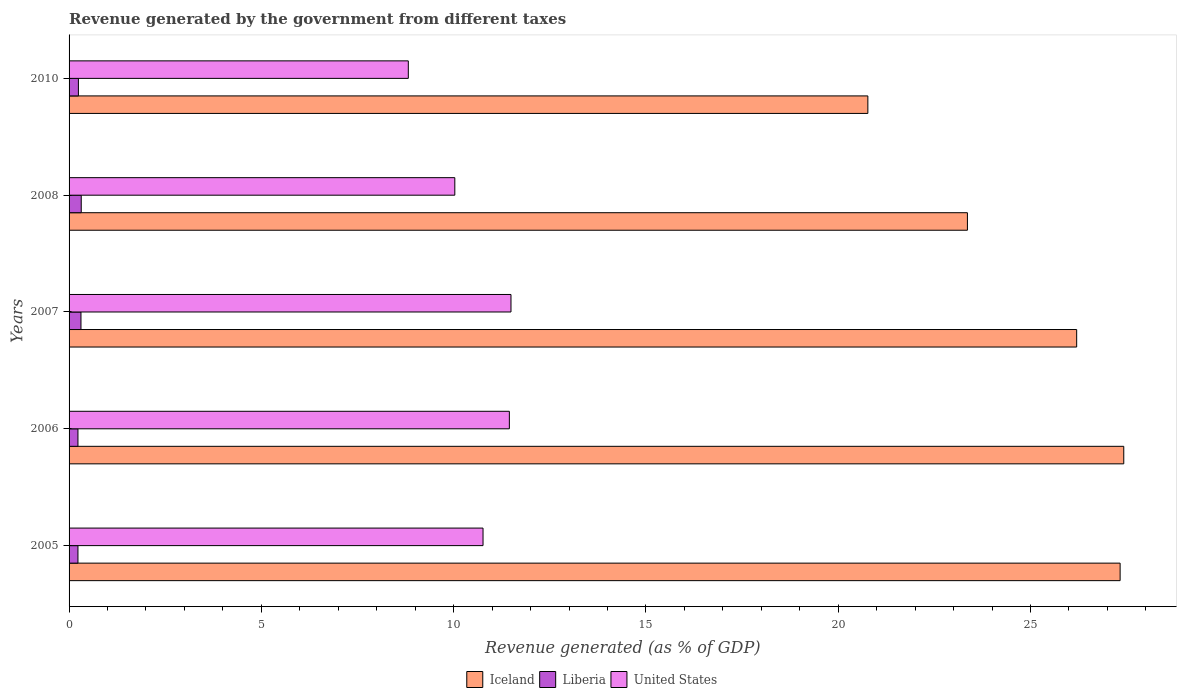How many different coloured bars are there?
Provide a succinct answer. 3. How many groups of bars are there?
Offer a very short reply. 5. How many bars are there on the 3rd tick from the bottom?
Ensure brevity in your answer.  3. What is the revenue generated by the government in Iceland in 2005?
Make the answer very short. 27.33. Across all years, what is the maximum revenue generated by the government in Liberia?
Provide a succinct answer. 0.32. Across all years, what is the minimum revenue generated by the government in United States?
Keep it short and to the point. 8.82. In which year was the revenue generated by the government in Liberia minimum?
Offer a very short reply. 2005. What is the total revenue generated by the government in United States in the graph?
Your answer should be very brief. 52.55. What is the difference between the revenue generated by the government in Iceland in 2005 and that in 2007?
Your answer should be compact. 1.13. What is the difference between the revenue generated by the government in United States in 2006 and the revenue generated by the government in Iceland in 2008?
Give a very brief answer. -11.91. What is the average revenue generated by the government in Iceland per year?
Offer a terse response. 25.02. In the year 2007, what is the difference between the revenue generated by the government in Liberia and revenue generated by the government in United States?
Your answer should be very brief. -11.18. In how many years, is the revenue generated by the government in Iceland greater than 13 %?
Give a very brief answer. 5. What is the ratio of the revenue generated by the government in Liberia in 2005 to that in 2010?
Offer a terse response. 0.95. Is the revenue generated by the government in United States in 2007 less than that in 2010?
Provide a short and direct response. No. What is the difference between the highest and the second highest revenue generated by the government in United States?
Make the answer very short. 0.04. What is the difference between the highest and the lowest revenue generated by the government in United States?
Provide a succinct answer. 2.67. In how many years, is the revenue generated by the government in Liberia greater than the average revenue generated by the government in Liberia taken over all years?
Keep it short and to the point. 2. What does the 2nd bar from the top in 2010 represents?
Offer a terse response. Liberia. What does the 2nd bar from the bottom in 2005 represents?
Keep it short and to the point. Liberia. Are all the bars in the graph horizontal?
Keep it short and to the point. Yes. How many years are there in the graph?
Provide a short and direct response. 5. What is the difference between two consecutive major ticks on the X-axis?
Provide a short and direct response. 5. What is the title of the graph?
Provide a short and direct response. Revenue generated by the government from different taxes. What is the label or title of the X-axis?
Your response must be concise. Revenue generated (as % of GDP). What is the label or title of the Y-axis?
Provide a succinct answer. Years. What is the Revenue generated (as % of GDP) of Iceland in 2005?
Your answer should be compact. 27.33. What is the Revenue generated (as % of GDP) of Liberia in 2005?
Offer a terse response. 0.23. What is the Revenue generated (as % of GDP) of United States in 2005?
Keep it short and to the point. 10.76. What is the Revenue generated (as % of GDP) in Iceland in 2006?
Provide a short and direct response. 27.42. What is the Revenue generated (as % of GDP) of Liberia in 2006?
Give a very brief answer. 0.23. What is the Revenue generated (as % of GDP) in United States in 2006?
Ensure brevity in your answer.  11.45. What is the Revenue generated (as % of GDP) in Iceland in 2007?
Make the answer very short. 26.2. What is the Revenue generated (as % of GDP) of Liberia in 2007?
Your response must be concise. 0.31. What is the Revenue generated (as % of GDP) of United States in 2007?
Ensure brevity in your answer.  11.49. What is the Revenue generated (as % of GDP) of Iceland in 2008?
Provide a succinct answer. 23.36. What is the Revenue generated (as % of GDP) of Liberia in 2008?
Offer a very short reply. 0.32. What is the Revenue generated (as % of GDP) of United States in 2008?
Your answer should be compact. 10.03. What is the Revenue generated (as % of GDP) of Iceland in 2010?
Offer a very short reply. 20.77. What is the Revenue generated (as % of GDP) of Liberia in 2010?
Provide a short and direct response. 0.24. What is the Revenue generated (as % of GDP) in United States in 2010?
Offer a very short reply. 8.82. Across all years, what is the maximum Revenue generated (as % of GDP) in Iceland?
Provide a succinct answer. 27.42. Across all years, what is the maximum Revenue generated (as % of GDP) in Liberia?
Your response must be concise. 0.32. Across all years, what is the maximum Revenue generated (as % of GDP) of United States?
Keep it short and to the point. 11.49. Across all years, what is the minimum Revenue generated (as % of GDP) in Iceland?
Ensure brevity in your answer.  20.77. Across all years, what is the minimum Revenue generated (as % of GDP) in Liberia?
Ensure brevity in your answer.  0.23. Across all years, what is the minimum Revenue generated (as % of GDP) in United States?
Ensure brevity in your answer.  8.82. What is the total Revenue generated (as % of GDP) in Iceland in the graph?
Offer a terse response. 125.08. What is the total Revenue generated (as % of GDP) of Liberia in the graph?
Your answer should be very brief. 1.33. What is the total Revenue generated (as % of GDP) of United States in the graph?
Give a very brief answer. 52.55. What is the difference between the Revenue generated (as % of GDP) in Iceland in 2005 and that in 2006?
Keep it short and to the point. -0.09. What is the difference between the Revenue generated (as % of GDP) in Liberia in 2005 and that in 2006?
Offer a terse response. -0. What is the difference between the Revenue generated (as % of GDP) of United States in 2005 and that in 2006?
Your answer should be compact. -0.68. What is the difference between the Revenue generated (as % of GDP) of Iceland in 2005 and that in 2007?
Your answer should be compact. 1.13. What is the difference between the Revenue generated (as % of GDP) in Liberia in 2005 and that in 2007?
Make the answer very short. -0.08. What is the difference between the Revenue generated (as % of GDP) in United States in 2005 and that in 2007?
Your answer should be very brief. -0.73. What is the difference between the Revenue generated (as % of GDP) in Iceland in 2005 and that in 2008?
Your response must be concise. 3.97. What is the difference between the Revenue generated (as % of GDP) of Liberia in 2005 and that in 2008?
Provide a succinct answer. -0.09. What is the difference between the Revenue generated (as % of GDP) in United States in 2005 and that in 2008?
Provide a succinct answer. 0.73. What is the difference between the Revenue generated (as % of GDP) in Iceland in 2005 and that in 2010?
Your answer should be compact. 6.56. What is the difference between the Revenue generated (as % of GDP) of Liberia in 2005 and that in 2010?
Your answer should be compact. -0.01. What is the difference between the Revenue generated (as % of GDP) in United States in 2005 and that in 2010?
Provide a succinct answer. 1.94. What is the difference between the Revenue generated (as % of GDP) in Iceland in 2006 and that in 2007?
Keep it short and to the point. 1.22. What is the difference between the Revenue generated (as % of GDP) of Liberia in 2006 and that in 2007?
Offer a very short reply. -0.08. What is the difference between the Revenue generated (as % of GDP) in United States in 2006 and that in 2007?
Your answer should be very brief. -0.04. What is the difference between the Revenue generated (as % of GDP) of Iceland in 2006 and that in 2008?
Give a very brief answer. 4.07. What is the difference between the Revenue generated (as % of GDP) in Liberia in 2006 and that in 2008?
Make the answer very short. -0.09. What is the difference between the Revenue generated (as % of GDP) of United States in 2006 and that in 2008?
Offer a terse response. 1.42. What is the difference between the Revenue generated (as % of GDP) in Iceland in 2006 and that in 2010?
Your response must be concise. 6.65. What is the difference between the Revenue generated (as % of GDP) of Liberia in 2006 and that in 2010?
Your answer should be very brief. -0.01. What is the difference between the Revenue generated (as % of GDP) in United States in 2006 and that in 2010?
Give a very brief answer. 2.63. What is the difference between the Revenue generated (as % of GDP) in Iceland in 2007 and that in 2008?
Offer a terse response. 2.84. What is the difference between the Revenue generated (as % of GDP) of Liberia in 2007 and that in 2008?
Provide a succinct answer. -0.01. What is the difference between the Revenue generated (as % of GDP) of United States in 2007 and that in 2008?
Make the answer very short. 1.46. What is the difference between the Revenue generated (as % of GDP) in Iceland in 2007 and that in 2010?
Provide a succinct answer. 5.43. What is the difference between the Revenue generated (as % of GDP) in Liberia in 2007 and that in 2010?
Your response must be concise. 0.07. What is the difference between the Revenue generated (as % of GDP) in United States in 2007 and that in 2010?
Make the answer very short. 2.67. What is the difference between the Revenue generated (as % of GDP) in Iceland in 2008 and that in 2010?
Your response must be concise. 2.59. What is the difference between the Revenue generated (as % of GDP) of Liberia in 2008 and that in 2010?
Give a very brief answer. 0.07. What is the difference between the Revenue generated (as % of GDP) in United States in 2008 and that in 2010?
Provide a short and direct response. 1.21. What is the difference between the Revenue generated (as % of GDP) of Iceland in 2005 and the Revenue generated (as % of GDP) of Liberia in 2006?
Your answer should be compact. 27.1. What is the difference between the Revenue generated (as % of GDP) in Iceland in 2005 and the Revenue generated (as % of GDP) in United States in 2006?
Provide a short and direct response. 15.88. What is the difference between the Revenue generated (as % of GDP) of Liberia in 2005 and the Revenue generated (as % of GDP) of United States in 2006?
Ensure brevity in your answer.  -11.22. What is the difference between the Revenue generated (as % of GDP) of Iceland in 2005 and the Revenue generated (as % of GDP) of Liberia in 2007?
Offer a very short reply. 27.02. What is the difference between the Revenue generated (as % of GDP) of Iceland in 2005 and the Revenue generated (as % of GDP) of United States in 2007?
Keep it short and to the point. 15.84. What is the difference between the Revenue generated (as % of GDP) in Liberia in 2005 and the Revenue generated (as % of GDP) in United States in 2007?
Your answer should be very brief. -11.26. What is the difference between the Revenue generated (as % of GDP) in Iceland in 2005 and the Revenue generated (as % of GDP) in Liberia in 2008?
Give a very brief answer. 27.01. What is the difference between the Revenue generated (as % of GDP) in Iceland in 2005 and the Revenue generated (as % of GDP) in United States in 2008?
Provide a succinct answer. 17.3. What is the difference between the Revenue generated (as % of GDP) of Liberia in 2005 and the Revenue generated (as % of GDP) of United States in 2008?
Offer a terse response. -9.8. What is the difference between the Revenue generated (as % of GDP) in Iceland in 2005 and the Revenue generated (as % of GDP) in Liberia in 2010?
Your answer should be very brief. 27.09. What is the difference between the Revenue generated (as % of GDP) in Iceland in 2005 and the Revenue generated (as % of GDP) in United States in 2010?
Keep it short and to the point. 18.51. What is the difference between the Revenue generated (as % of GDP) of Liberia in 2005 and the Revenue generated (as % of GDP) of United States in 2010?
Offer a very short reply. -8.59. What is the difference between the Revenue generated (as % of GDP) in Iceland in 2006 and the Revenue generated (as % of GDP) in Liberia in 2007?
Ensure brevity in your answer.  27.11. What is the difference between the Revenue generated (as % of GDP) in Iceland in 2006 and the Revenue generated (as % of GDP) in United States in 2007?
Give a very brief answer. 15.93. What is the difference between the Revenue generated (as % of GDP) in Liberia in 2006 and the Revenue generated (as % of GDP) in United States in 2007?
Your answer should be compact. -11.26. What is the difference between the Revenue generated (as % of GDP) in Iceland in 2006 and the Revenue generated (as % of GDP) in Liberia in 2008?
Offer a very short reply. 27.11. What is the difference between the Revenue generated (as % of GDP) in Iceland in 2006 and the Revenue generated (as % of GDP) in United States in 2008?
Give a very brief answer. 17.39. What is the difference between the Revenue generated (as % of GDP) in Liberia in 2006 and the Revenue generated (as % of GDP) in United States in 2008?
Your answer should be compact. -9.8. What is the difference between the Revenue generated (as % of GDP) of Iceland in 2006 and the Revenue generated (as % of GDP) of Liberia in 2010?
Your answer should be compact. 27.18. What is the difference between the Revenue generated (as % of GDP) of Iceland in 2006 and the Revenue generated (as % of GDP) of United States in 2010?
Ensure brevity in your answer.  18.6. What is the difference between the Revenue generated (as % of GDP) of Liberia in 2006 and the Revenue generated (as % of GDP) of United States in 2010?
Give a very brief answer. -8.59. What is the difference between the Revenue generated (as % of GDP) of Iceland in 2007 and the Revenue generated (as % of GDP) of Liberia in 2008?
Offer a terse response. 25.88. What is the difference between the Revenue generated (as % of GDP) of Iceland in 2007 and the Revenue generated (as % of GDP) of United States in 2008?
Provide a succinct answer. 16.17. What is the difference between the Revenue generated (as % of GDP) in Liberia in 2007 and the Revenue generated (as % of GDP) in United States in 2008?
Make the answer very short. -9.72. What is the difference between the Revenue generated (as % of GDP) in Iceland in 2007 and the Revenue generated (as % of GDP) in Liberia in 2010?
Your answer should be compact. 25.96. What is the difference between the Revenue generated (as % of GDP) in Iceland in 2007 and the Revenue generated (as % of GDP) in United States in 2010?
Ensure brevity in your answer.  17.38. What is the difference between the Revenue generated (as % of GDP) in Liberia in 2007 and the Revenue generated (as % of GDP) in United States in 2010?
Make the answer very short. -8.51. What is the difference between the Revenue generated (as % of GDP) in Iceland in 2008 and the Revenue generated (as % of GDP) in Liberia in 2010?
Keep it short and to the point. 23.12. What is the difference between the Revenue generated (as % of GDP) in Iceland in 2008 and the Revenue generated (as % of GDP) in United States in 2010?
Make the answer very short. 14.54. What is the difference between the Revenue generated (as % of GDP) in Liberia in 2008 and the Revenue generated (as % of GDP) in United States in 2010?
Make the answer very short. -8.5. What is the average Revenue generated (as % of GDP) in Iceland per year?
Ensure brevity in your answer.  25.02. What is the average Revenue generated (as % of GDP) of Liberia per year?
Keep it short and to the point. 0.27. What is the average Revenue generated (as % of GDP) of United States per year?
Your answer should be compact. 10.51. In the year 2005, what is the difference between the Revenue generated (as % of GDP) of Iceland and Revenue generated (as % of GDP) of Liberia?
Ensure brevity in your answer.  27.1. In the year 2005, what is the difference between the Revenue generated (as % of GDP) in Iceland and Revenue generated (as % of GDP) in United States?
Offer a very short reply. 16.57. In the year 2005, what is the difference between the Revenue generated (as % of GDP) of Liberia and Revenue generated (as % of GDP) of United States?
Keep it short and to the point. -10.53. In the year 2006, what is the difference between the Revenue generated (as % of GDP) of Iceland and Revenue generated (as % of GDP) of Liberia?
Make the answer very short. 27.19. In the year 2006, what is the difference between the Revenue generated (as % of GDP) in Iceland and Revenue generated (as % of GDP) in United States?
Offer a terse response. 15.98. In the year 2006, what is the difference between the Revenue generated (as % of GDP) of Liberia and Revenue generated (as % of GDP) of United States?
Offer a very short reply. -11.22. In the year 2007, what is the difference between the Revenue generated (as % of GDP) in Iceland and Revenue generated (as % of GDP) in Liberia?
Offer a terse response. 25.89. In the year 2007, what is the difference between the Revenue generated (as % of GDP) in Iceland and Revenue generated (as % of GDP) in United States?
Ensure brevity in your answer.  14.71. In the year 2007, what is the difference between the Revenue generated (as % of GDP) in Liberia and Revenue generated (as % of GDP) in United States?
Your response must be concise. -11.18. In the year 2008, what is the difference between the Revenue generated (as % of GDP) in Iceland and Revenue generated (as % of GDP) in Liberia?
Keep it short and to the point. 23.04. In the year 2008, what is the difference between the Revenue generated (as % of GDP) of Iceland and Revenue generated (as % of GDP) of United States?
Make the answer very short. 13.33. In the year 2008, what is the difference between the Revenue generated (as % of GDP) in Liberia and Revenue generated (as % of GDP) in United States?
Your answer should be compact. -9.71. In the year 2010, what is the difference between the Revenue generated (as % of GDP) of Iceland and Revenue generated (as % of GDP) of Liberia?
Make the answer very short. 20.53. In the year 2010, what is the difference between the Revenue generated (as % of GDP) of Iceland and Revenue generated (as % of GDP) of United States?
Your response must be concise. 11.95. In the year 2010, what is the difference between the Revenue generated (as % of GDP) of Liberia and Revenue generated (as % of GDP) of United States?
Provide a succinct answer. -8.58. What is the ratio of the Revenue generated (as % of GDP) of Iceland in 2005 to that in 2006?
Your answer should be very brief. 1. What is the ratio of the Revenue generated (as % of GDP) of Liberia in 2005 to that in 2006?
Give a very brief answer. 1. What is the ratio of the Revenue generated (as % of GDP) in United States in 2005 to that in 2006?
Give a very brief answer. 0.94. What is the ratio of the Revenue generated (as % of GDP) of Iceland in 2005 to that in 2007?
Your answer should be compact. 1.04. What is the ratio of the Revenue generated (as % of GDP) in Liberia in 2005 to that in 2007?
Ensure brevity in your answer.  0.75. What is the ratio of the Revenue generated (as % of GDP) in United States in 2005 to that in 2007?
Provide a succinct answer. 0.94. What is the ratio of the Revenue generated (as % of GDP) in Iceland in 2005 to that in 2008?
Keep it short and to the point. 1.17. What is the ratio of the Revenue generated (as % of GDP) in Liberia in 2005 to that in 2008?
Offer a very short reply. 0.73. What is the ratio of the Revenue generated (as % of GDP) in United States in 2005 to that in 2008?
Give a very brief answer. 1.07. What is the ratio of the Revenue generated (as % of GDP) in Iceland in 2005 to that in 2010?
Provide a short and direct response. 1.32. What is the ratio of the Revenue generated (as % of GDP) of Liberia in 2005 to that in 2010?
Offer a terse response. 0.95. What is the ratio of the Revenue generated (as % of GDP) in United States in 2005 to that in 2010?
Give a very brief answer. 1.22. What is the ratio of the Revenue generated (as % of GDP) of Iceland in 2006 to that in 2007?
Offer a very short reply. 1.05. What is the ratio of the Revenue generated (as % of GDP) of Liberia in 2006 to that in 2007?
Give a very brief answer. 0.75. What is the ratio of the Revenue generated (as % of GDP) of Iceland in 2006 to that in 2008?
Keep it short and to the point. 1.17. What is the ratio of the Revenue generated (as % of GDP) of Liberia in 2006 to that in 2008?
Ensure brevity in your answer.  0.73. What is the ratio of the Revenue generated (as % of GDP) in United States in 2006 to that in 2008?
Give a very brief answer. 1.14. What is the ratio of the Revenue generated (as % of GDP) in Iceland in 2006 to that in 2010?
Offer a very short reply. 1.32. What is the ratio of the Revenue generated (as % of GDP) of Liberia in 2006 to that in 2010?
Keep it short and to the point. 0.95. What is the ratio of the Revenue generated (as % of GDP) in United States in 2006 to that in 2010?
Offer a very short reply. 1.3. What is the ratio of the Revenue generated (as % of GDP) in Iceland in 2007 to that in 2008?
Provide a succinct answer. 1.12. What is the ratio of the Revenue generated (as % of GDP) in Liberia in 2007 to that in 2008?
Provide a short and direct response. 0.98. What is the ratio of the Revenue generated (as % of GDP) in United States in 2007 to that in 2008?
Give a very brief answer. 1.15. What is the ratio of the Revenue generated (as % of GDP) in Iceland in 2007 to that in 2010?
Keep it short and to the point. 1.26. What is the ratio of the Revenue generated (as % of GDP) of Liberia in 2007 to that in 2010?
Keep it short and to the point. 1.28. What is the ratio of the Revenue generated (as % of GDP) in United States in 2007 to that in 2010?
Your answer should be very brief. 1.3. What is the ratio of the Revenue generated (as % of GDP) of Iceland in 2008 to that in 2010?
Provide a short and direct response. 1.12. What is the ratio of the Revenue generated (as % of GDP) of Liberia in 2008 to that in 2010?
Your answer should be very brief. 1.3. What is the ratio of the Revenue generated (as % of GDP) in United States in 2008 to that in 2010?
Your response must be concise. 1.14. What is the difference between the highest and the second highest Revenue generated (as % of GDP) of Iceland?
Your answer should be very brief. 0.09. What is the difference between the highest and the second highest Revenue generated (as % of GDP) in Liberia?
Ensure brevity in your answer.  0.01. What is the difference between the highest and the second highest Revenue generated (as % of GDP) of United States?
Offer a terse response. 0.04. What is the difference between the highest and the lowest Revenue generated (as % of GDP) in Iceland?
Your answer should be very brief. 6.65. What is the difference between the highest and the lowest Revenue generated (as % of GDP) in Liberia?
Your answer should be very brief. 0.09. What is the difference between the highest and the lowest Revenue generated (as % of GDP) of United States?
Ensure brevity in your answer.  2.67. 